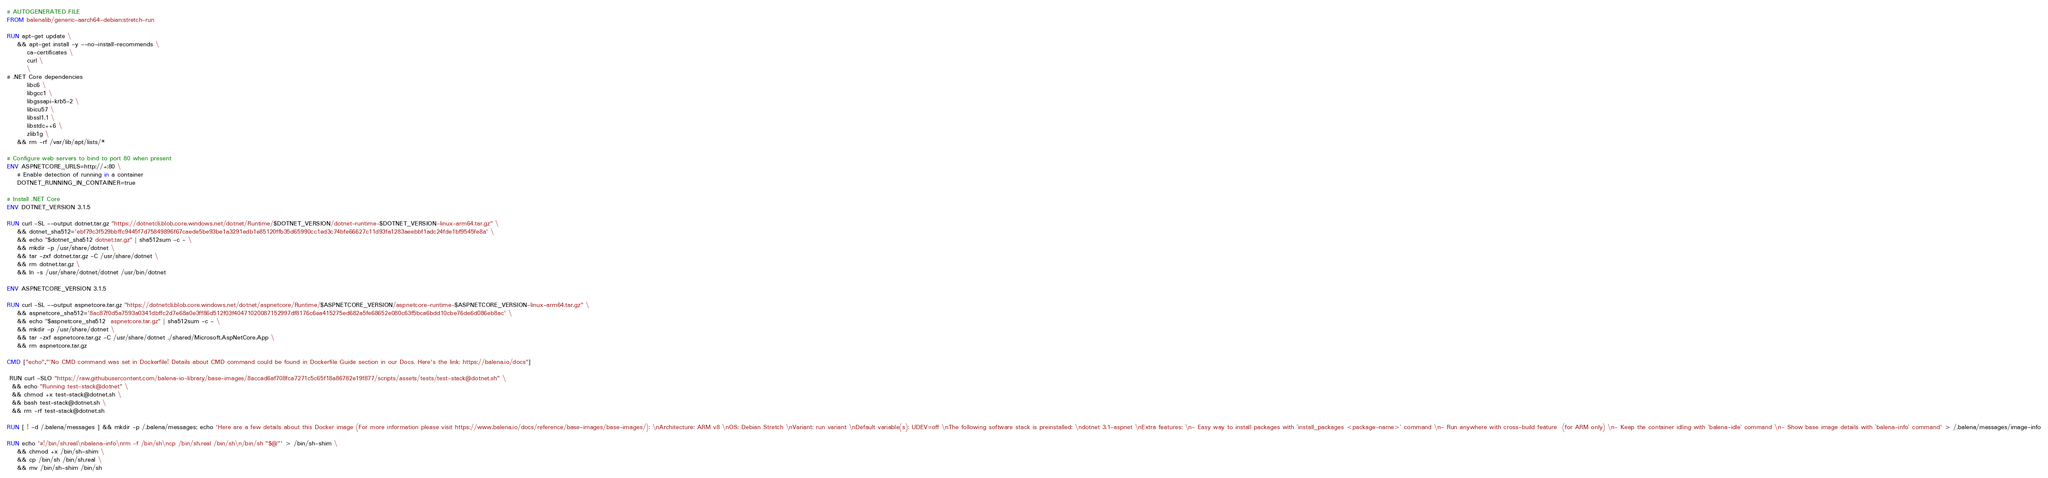Convert code to text. <code><loc_0><loc_0><loc_500><loc_500><_Dockerfile_># AUTOGENERATED FILE
FROM balenalib/generic-aarch64-debian:stretch-run

RUN apt-get update \
    && apt-get install -y --no-install-recommends \
        ca-certificates \
        curl \
        \
# .NET Core dependencies
        libc6 \
        libgcc1 \
        libgssapi-krb5-2 \
        libicu57 \
        libssl1.1 \
        libstdc++6 \
        zlib1g \
    && rm -rf /var/lib/apt/lists/*

# Configure web servers to bind to port 80 when present
ENV ASPNETCORE_URLS=http://+:80 \
    # Enable detection of running in a container
    DOTNET_RUNNING_IN_CONTAINER=true

# Install .NET Core
ENV DOTNET_VERSION 3.1.5

RUN curl -SL --output dotnet.tar.gz "https://dotnetcli.blob.core.windows.net/dotnet/Runtime/$DOTNET_VERSION/dotnet-runtime-$DOTNET_VERSION-linux-arm64.tar.gz" \
    && dotnet_sha512='ebf79c3f529bbffc9445f7d75849896f67caede5be93be1a3291edb1e85120ffb35d65990cc1ed3c74bfe66627c11d93fa1283aeebbf1adc24fde1bf9545fe8a' \
    && echo "$dotnet_sha512 dotnet.tar.gz" | sha512sum -c - \
    && mkdir -p /usr/share/dotnet \
    && tar -zxf dotnet.tar.gz -C /usr/share/dotnet \
    && rm dotnet.tar.gz \
    && ln -s /usr/share/dotnet/dotnet /usr/bin/dotnet

ENV ASPNETCORE_VERSION 3.1.5

RUN curl -SL --output aspnetcore.tar.gz "https://dotnetcli.blob.core.windows.net/dotnet/aspnetcore/Runtime/$ASPNETCORE_VERSION/aspnetcore-runtime-$ASPNETCORE_VERSION-linux-arm64.tar.gz" \
    && aspnetcore_sha512='8ac87f0d5a7593a0341dbffc2d7e68a0e3ff86d512f03f40471020087152997df8176c6ea415275ed682a5fe68652e080c63f5bca6bdd10cbe76de6d086eb8ac' \
    && echo "$aspnetcore_sha512  aspnetcore.tar.gz" | sha512sum -c - \
    && mkdir -p /usr/share/dotnet \
    && tar -zxf aspnetcore.tar.gz -C /usr/share/dotnet ./shared/Microsoft.AspNetCore.App \
    && rm aspnetcore.tar.gz

CMD ["echo","'No CMD command was set in Dockerfile! Details about CMD command could be found in Dockerfile Guide section in our Docs. Here's the link: https://balena.io/docs"]

 RUN curl -SLO "https://raw.githubusercontent.com/balena-io-library/base-images/8accad6af708fca7271c5c65f18a86782e19f877/scripts/assets/tests/test-stack@dotnet.sh" \
  && echo "Running test-stack@dotnet" \
  && chmod +x test-stack@dotnet.sh \
  && bash test-stack@dotnet.sh \
  && rm -rf test-stack@dotnet.sh 

RUN [ ! -d /.balena/messages ] && mkdir -p /.balena/messages; echo 'Here are a few details about this Docker image (For more information please visit https://www.balena.io/docs/reference/base-images/base-images/): \nArchitecture: ARM v8 \nOS: Debian Stretch \nVariant: run variant \nDefault variable(s): UDEV=off \nThe following software stack is preinstalled: \ndotnet 3.1-aspnet \nExtra features: \n- Easy way to install packages with `install_packages <package-name>` command \n- Run anywhere with cross-build feature  (for ARM only) \n- Keep the container idling with `balena-idle` command \n- Show base image details with `balena-info` command' > /.balena/messages/image-info

RUN echo '#!/bin/sh.real\nbalena-info\nrm -f /bin/sh\ncp /bin/sh.real /bin/sh\n/bin/sh "$@"' > /bin/sh-shim \
	&& chmod +x /bin/sh-shim \
	&& cp /bin/sh /bin/sh.real \
	&& mv /bin/sh-shim /bin/sh</code> 